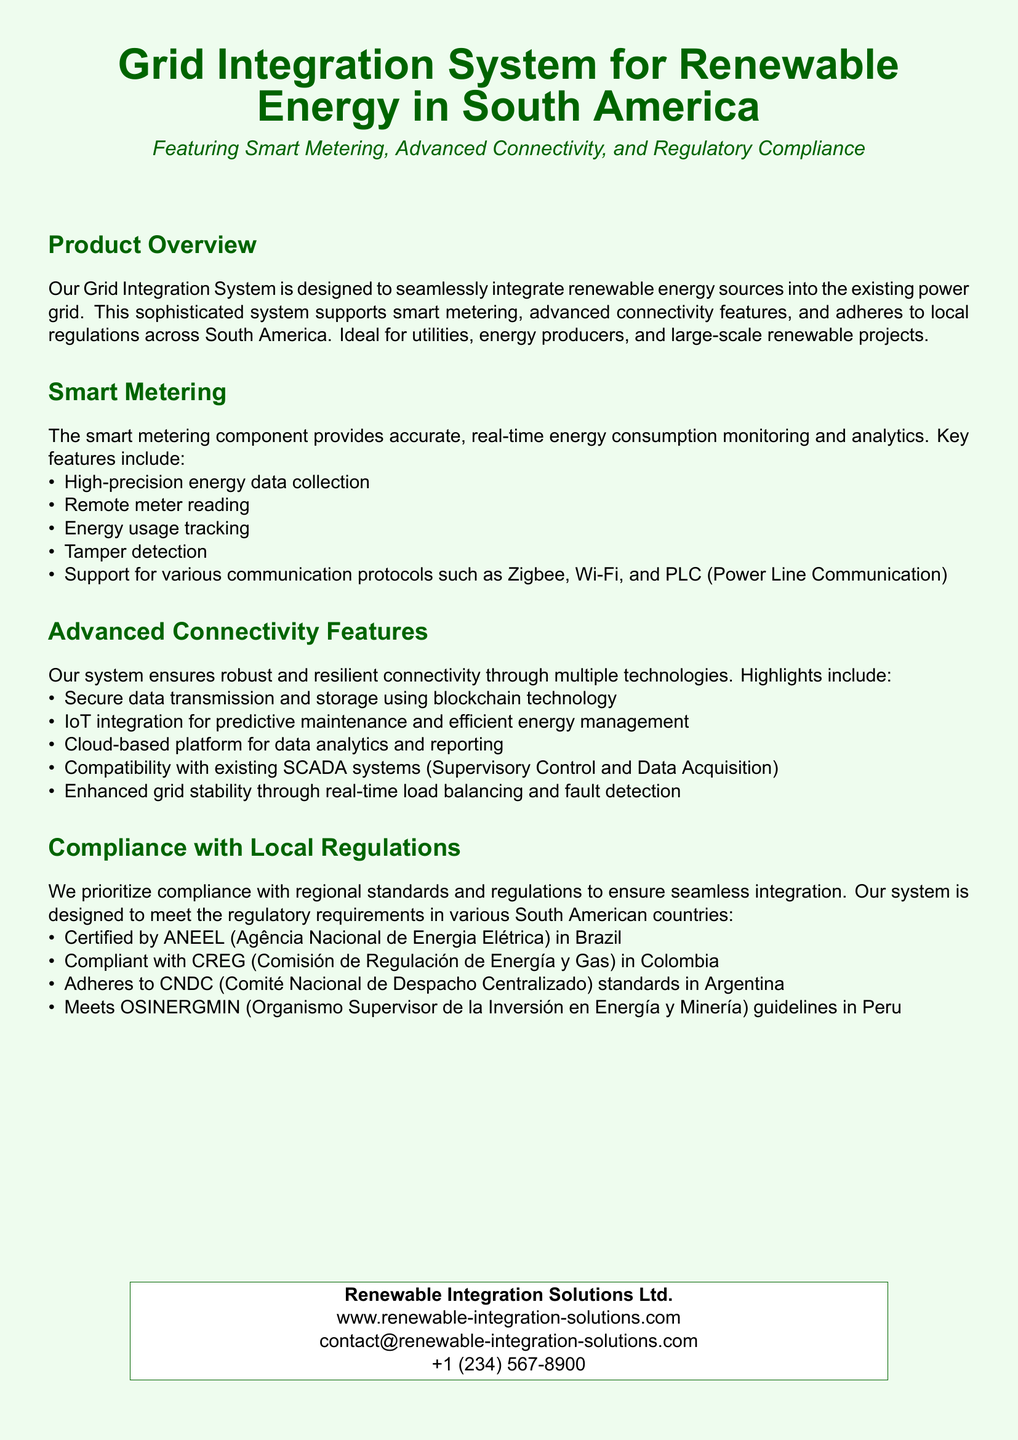What is the primary purpose of the Grid Integration System? The primary purpose is to seamlessly integrate renewable energy sources into the existing power grid.
Answer: To seamlessly integrate renewable energy sources into the existing power grid What technologies are supported for communication in smart metering? The document lists several communication protocols used in smart metering, specifically mentioning Zigbee, Wi-Fi, and PLC.
Answer: Zigbee, Wi-Fi, and PLC How many local regulations does the product comply with? The document lists four regulatory compliance standards referenced for different countries in South America.
Answer: Four Which organization certifies the product in Brazil? The document states that the certification is by ANEEL, the Agência Nacional de Energia Elétrica.
Answer: ANEEL What type of data security is implemented in the connectivity features? The document mentions secure data transmission and storage using blockchain technology.
Answer: Blockchain technology What is one of the advanced connectivity features related to maintenance? The document states that IoT integration enables predictive maintenance for efficient energy management.
Answer: Predictive maintenance Which cloud capability is mentioned in the connectivity features? The document specifies that a cloud-based platform is used for data analytics and reporting.
Answer: Data analytics and reporting What is the role of SCADA systems in the Grid Integration System? The document indicates that the system is compatible with existing SCADA systems.
Answer: Compatibility with existing SCADA systems 